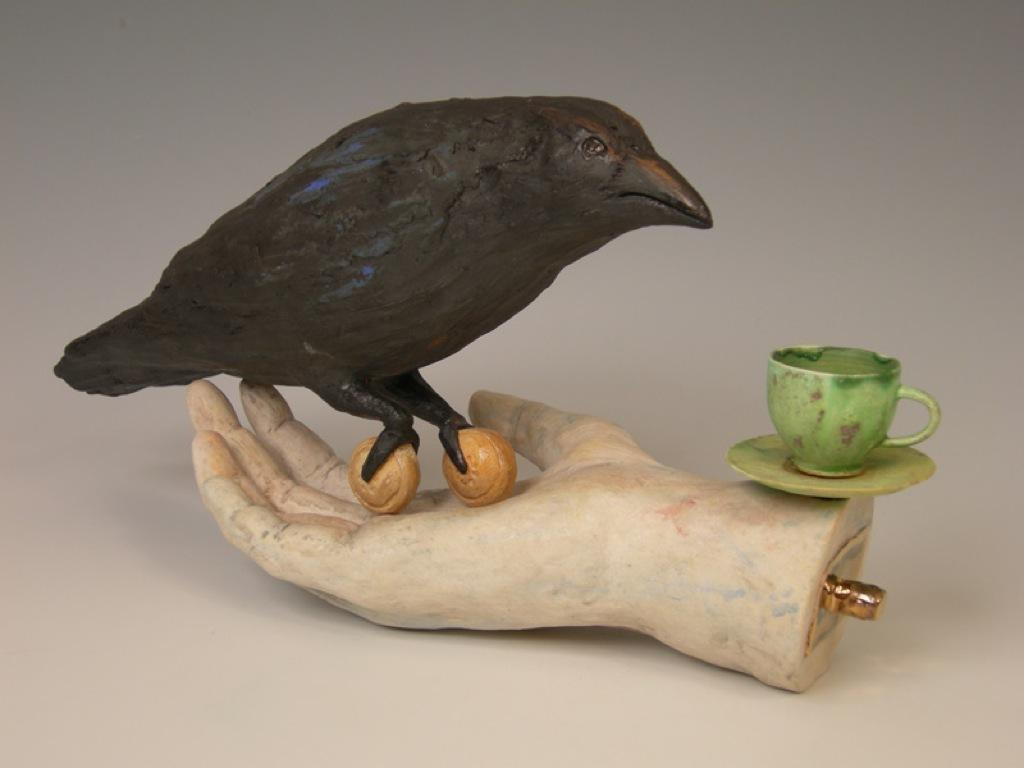What is the main subject of the image? There is a statue of a bird in the image. What color are the objects in the image? The objects in the image are cream-colored. What part of a person is visible in the image? A human hand is visible in the image. What is the bird statue standing on in the image? There is a cup and a saucer in the image. How does the statue of the bird make a suggestion in the image? The statue of the bird is not capable of making suggestions, as it is an inanimate object. What type of hearing aid is visible on the bird statue in the image? There is no hearing aid present on the bird statue in the image. 